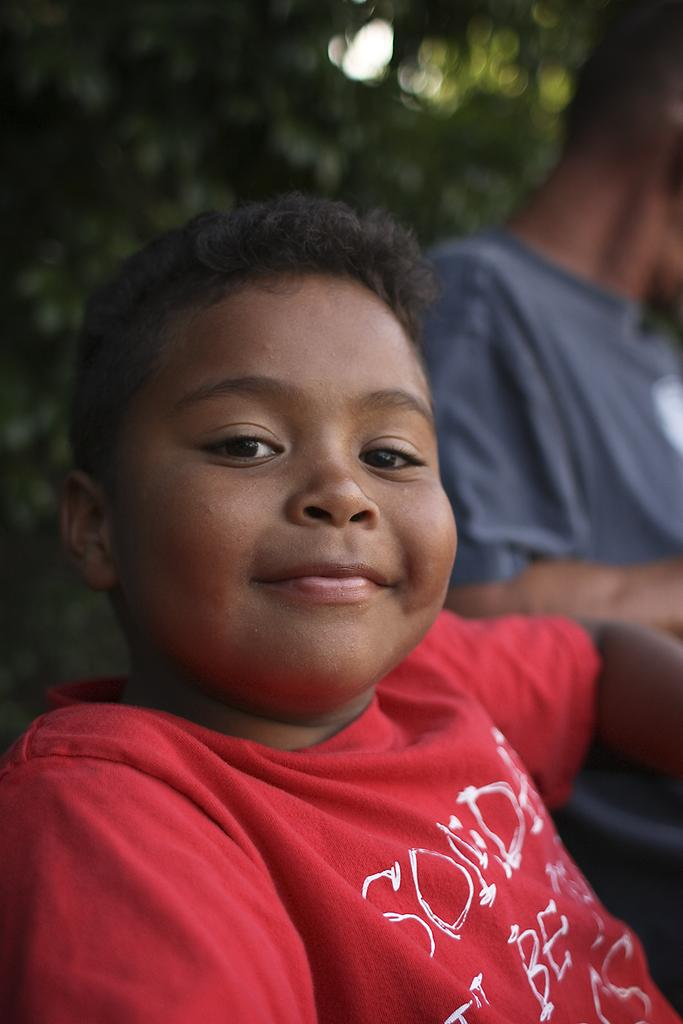What is the main subject of the image? The main subject of the image is a picture of a boy. How is the background of the boy depicted in the image? The background of the boy is blurred in the image. What type of wheel can be seen in the image? There is no wheel present in the image; it features a picture of a boy with a blurred background. What time of day is it in the image? The time of day is not specified in the image, as it only shows a picture of a boy with a blurred background. 